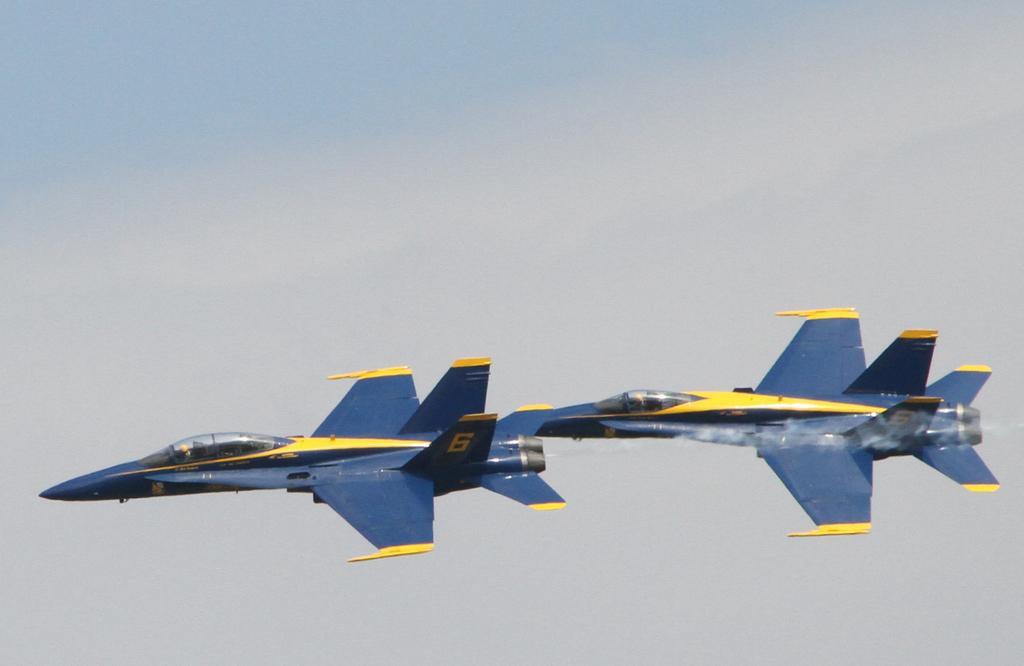<image>
Create a compact narrative representing the image presented. Two blue airplanes fly together, each with 6 on their tails. 